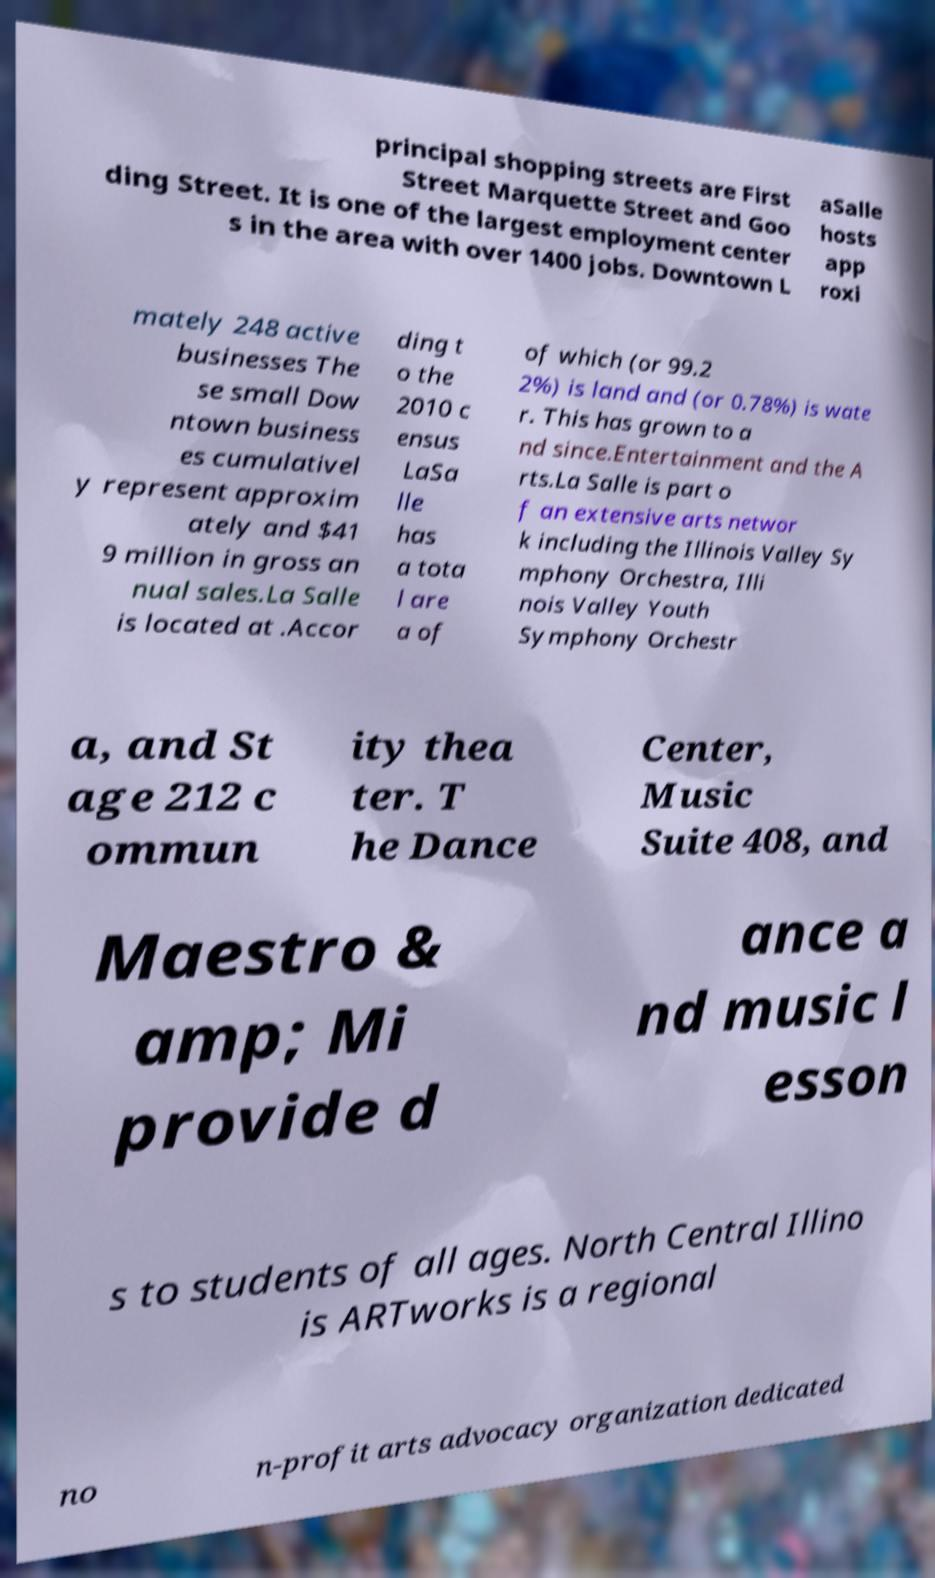I need the written content from this picture converted into text. Can you do that? principal shopping streets are First Street Marquette Street and Goo ding Street. It is one of the largest employment center s in the area with over 1400 jobs. Downtown L aSalle hosts app roxi mately 248 active businesses The se small Dow ntown business es cumulativel y represent approxim ately and $41 9 million in gross an nual sales.La Salle is located at .Accor ding t o the 2010 c ensus LaSa lle has a tota l are a of of which (or 99.2 2%) is land and (or 0.78%) is wate r. This has grown to a nd since.Entertainment and the A rts.La Salle is part o f an extensive arts networ k including the Illinois Valley Sy mphony Orchestra, Illi nois Valley Youth Symphony Orchestr a, and St age 212 c ommun ity thea ter. T he Dance Center, Music Suite 408, and Maestro & amp; Mi provide d ance a nd music l esson s to students of all ages. North Central Illino is ARTworks is a regional no n-profit arts advocacy organization dedicated 